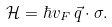<formula> <loc_0><loc_0><loc_500><loc_500>\mathcal { H } = \hbar { v } _ { F } \, \vec { q } \cdot \sigma .</formula> 